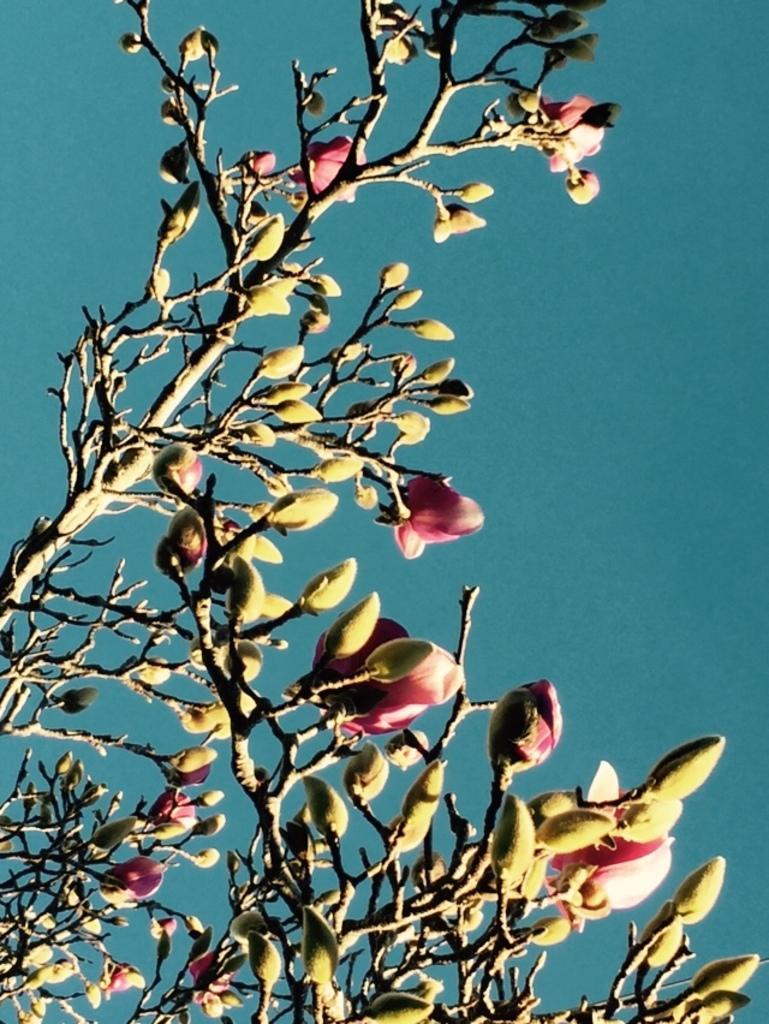In one or two sentences, can you explain what this image depicts? In this image there is a tree and we can see flowers and buds. In the background there is sky. 